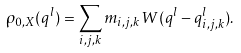Convert formula to latex. <formula><loc_0><loc_0><loc_500><loc_500>\rho _ { 0 , X } ( q ^ { l } ) = \sum _ { i , j , k } m _ { i , j , k } W ( q ^ { l } - q ^ { l } _ { i , j , k } ) .</formula> 